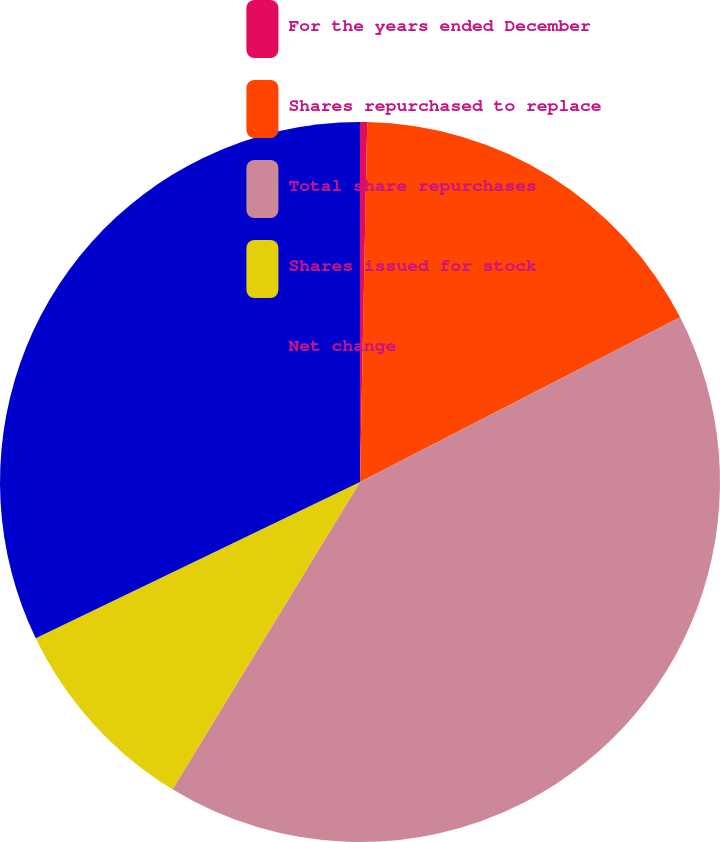Convert chart to OTSL. <chart><loc_0><loc_0><loc_500><loc_500><pie_chart><fcel>For the years ended December<fcel>Shares repurchased to replace<fcel>Total share repurchases<fcel>Shares issued for stock<fcel>Net change<nl><fcel>0.32%<fcel>17.12%<fcel>41.28%<fcel>9.13%<fcel>32.15%<nl></chart> 